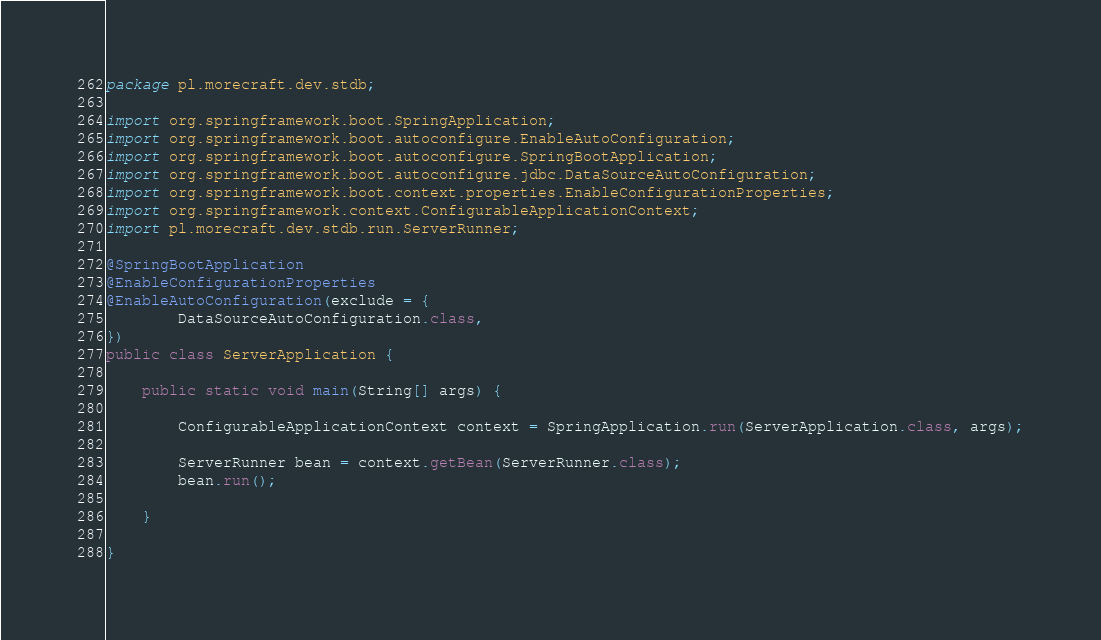Convert code to text. <code><loc_0><loc_0><loc_500><loc_500><_Java_>package pl.morecraft.dev.stdb;

import org.springframework.boot.SpringApplication;
import org.springframework.boot.autoconfigure.EnableAutoConfiguration;
import org.springframework.boot.autoconfigure.SpringBootApplication;
import org.springframework.boot.autoconfigure.jdbc.DataSourceAutoConfiguration;
import org.springframework.boot.context.properties.EnableConfigurationProperties;
import org.springframework.context.ConfigurableApplicationContext;
import pl.morecraft.dev.stdb.run.ServerRunner;

@SpringBootApplication
@EnableConfigurationProperties
@EnableAutoConfiguration(exclude = {
        DataSourceAutoConfiguration.class,
})
public class ServerApplication {

    public static void main(String[] args) {

        ConfigurableApplicationContext context = SpringApplication.run(ServerApplication.class, args);

        ServerRunner bean = context.getBean(ServerRunner.class);
        bean.run();

    }

}
</code> 